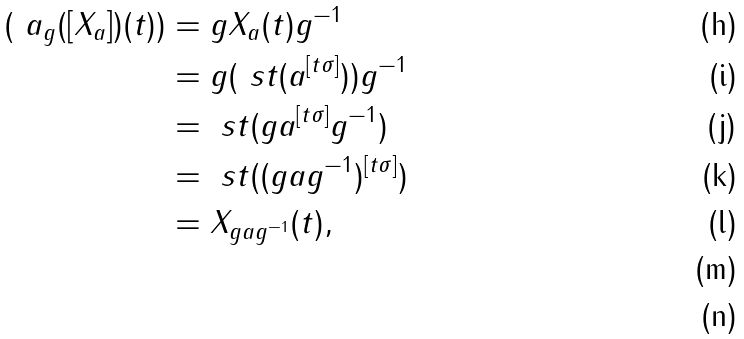Convert formula to latex. <formula><loc_0><loc_0><loc_500><loc_500>( \ a _ { g } ( [ X _ { a } ] ) ( t ) ) & = g X _ { a } ( t ) g ^ { - 1 } \\ & = g ( \ s t ( a ^ { [ t \sigma ] } ) ) g ^ { - 1 } \\ & = \ s t ( g a ^ { [ t \sigma ] } g ^ { - 1 } ) \\ & = \ s t ( ( g a g ^ { - 1 } ) ^ { [ t \sigma ] } ) \\ & = X _ { g a g ^ { - 1 } } ( t ) , \\ \\</formula> 